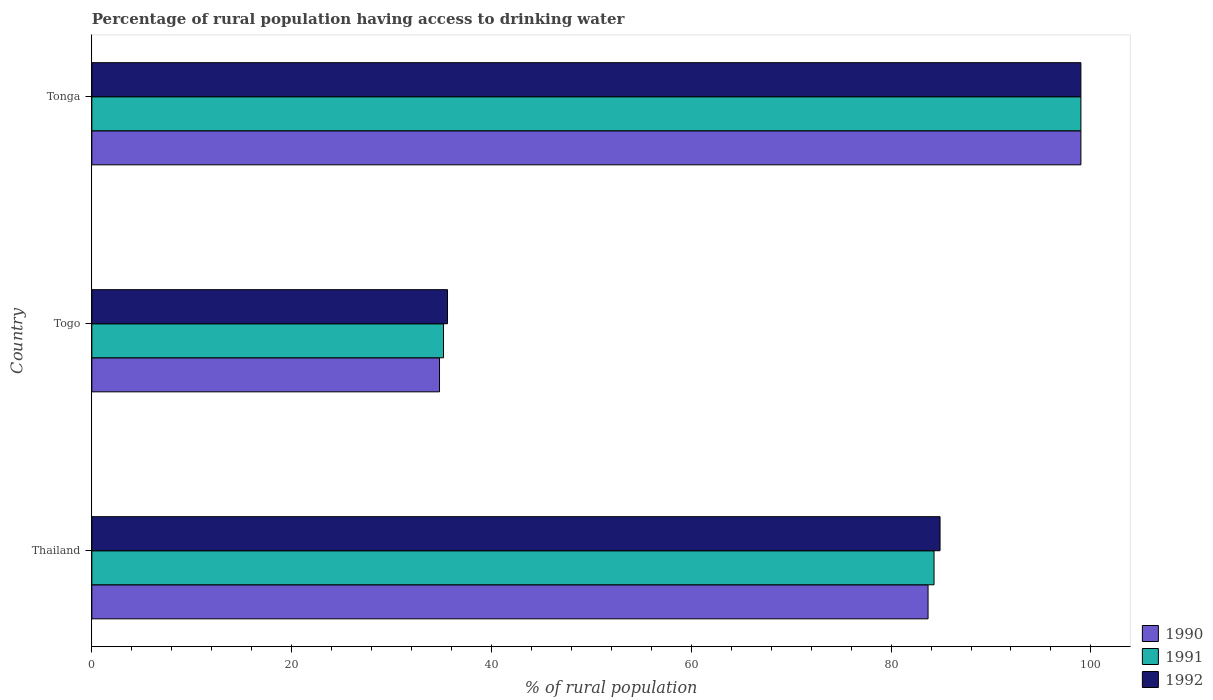How many different coloured bars are there?
Your answer should be compact. 3. How many bars are there on the 1st tick from the bottom?
Your response must be concise. 3. What is the label of the 1st group of bars from the top?
Your answer should be very brief. Tonga. In how many cases, is the number of bars for a given country not equal to the number of legend labels?
Provide a short and direct response. 0. What is the percentage of rural population having access to drinking water in 1990 in Togo?
Ensure brevity in your answer.  34.8. Across all countries, what is the maximum percentage of rural population having access to drinking water in 1991?
Your answer should be compact. 99. Across all countries, what is the minimum percentage of rural population having access to drinking water in 1990?
Keep it short and to the point. 34.8. In which country was the percentage of rural population having access to drinking water in 1992 maximum?
Provide a succinct answer. Tonga. In which country was the percentage of rural population having access to drinking water in 1990 minimum?
Give a very brief answer. Togo. What is the total percentage of rural population having access to drinking water in 1991 in the graph?
Provide a succinct answer. 218.5. What is the difference between the percentage of rural population having access to drinking water in 1990 in Thailand and that in Tonga?
Offer a terse response. -15.3. What is the difference between the percentage of rural population having access to drinking water in 1991 in Tonga and the percentage of rural population having access to drinking water in 1990 in Togo?
Ensure brevity in your answer.  64.2. What is the average percentage of rural population having access to drinking water in 1992 per country?
Provide a succinct answer. 73.17. What is the difference between the percentage of rural population having access to drinking water in 1991 and percentage of rural population having access to drinking water in 1992 in Thailand?
Give a very brief answer. -0.6. In how many countries, is the percentage of rural population having access to drinking water in 1991 greater than 40 %?
Give a very brief answer. 2. What is the ratio of the percentage of rural population having access to drinking water in 1991 in Thailand to that in Tonga?
Ensure brevity in your answer.  0.85. What is the difference between the highest and the second highest percentage of rural population having access to drinking water in 1990?
Provide a succinct answer. 15.3. What is the difference between the highest and the lowest percentage of rural population having access to drinking water in 1990?
Offer a terse response. 64.2. Is the sum of the percentage of rural population having access to drinking water in 1992 in Thailand and Togo greater than the maximum percentage of rural population having access to drinking water in 1990 across all countries?
Keep it short and to the point. Yes. Is it the case that in every country, the sum of the percentage of rural population having access to drinking water in 1992 and percentage of rural population having access to drinking water in 1991 is greater than the percentage of rural population having access to drinking water in 1990?
Provide a short and direct response. Yes. How many bars are there?
Your answer should be very brief. 9. Are all the bars in the graph horizontal?
Offer a very short reply. Yes. How many countries are there in the graph?
Your answer should be very brief. 3. What is the difference between two consecutive major ticks on the X-axis?
Your answer should be compact. 20. Are the values on the major ticks of X-axis written in scientific E-notation?
Your answer should be very brief. No. Does the graph contain any zero values?
Provide a succinct answer. No. How many legend labels are there?
Offer a very short reply. 3. How are the legend labels stacked?
Your answer should be compact. Vertical. What is the title of the graph?
Give a very brief answer. Percentage of rural population having access to drinking water. Does "1975" appear as one of the legend labels in the graph?
Your answer should be very brief. No. What is the label or title of the X-axis?
Your answer should be very brief. % of rural population. What is the % of rural population of 1990 in Thailand?
Offer a very short reply. 83.7. What is the % of rural population in 1991 in Thailand?
Your response must be concise. 84.3. What is the % of rural population in 1992 in Thailand?
Provide a succinct answer. 84.9. What is the % of rural population of 1990 in Togo?
Provide a short and direct response. 34.8. What is the % of rural population in 1991 in Togo?
Offer a terse response. 35.2. What is the % of rural population in 1992 in Togo?
Give a very brief answer. 35.6. What is the % of rural population of 1992 in Tonga?
Your answer should be very brief. 99. Across all countries, what is the minimum % of rural population of 1990?
Provide a short and direct response. 34.8. Across all countries, what is the minimum % of rural population of 1991?
Offer a terse response. 35.2. Across all countries, what is the minimum % of rural population in 1992?
Offer a very short reply. 35.6. What is the total % of rural population of 1990 in the graph?
Your answer should be very brief. 217.5. What is the total % of rural population in 1991 in the graph?
Keep it short and to the point. 218.5. What is the total % of rural population of 1992 in the graph?
Provide a succinct answer. 219.5. What is the difference between the % of rural population of 1990 in Thailand and that in Togo?
Offer a terse response. 48.9. What is the difference between the % of rural population in 1991 in Thailand and that in Togo?
Provide a succinct answer. 49.1. What is the difference between the % of rural population in 1992 in Thailand and that in Togo?
Keep it short and to the point. 49.3. What is the difference between the % of rural population of 1990 in Thailand and that in Tonga?
Offer a very short reply. -15.3. What is the difference between the % of rural population of 1991 in Thailand and that in Tonga?
Your response must be concise. -14.7. What is the difference between the % of rural population of 1992 in Thailand and that in Tonga?
Your answer should be very brief. -14.1. What is the difference between the % of rural population in 1990 in Togo and that in Tonga?
Offer a very short reply. -64.2. What is the difference between the % of rural population of 1991 in Togo and that in Tonga?
Offer a very short reply. -63.8. What is the difference between the % of rural population of 1992 in Togo and that in Tonga?
Your response must be concise. -63.4. What is the difference between the % of rural population of 1990 in Thailand and the % of rural population of 1991 in Togo?
Your answer should be very brief. 48.5. What is the difference between the % of rural population in 1990 in Thailand and the % of rural population in 1992 in Togo?
Your answer should be compact. 48.1. What is the difference between the % of rural population of 1991 in Thailand and the % of rural population of 1992 in Togo?
Your answer should be very brief. 48.7. What is the difference between the % of rural population in 1990 in Thailand and the % of rural population in 1991 in Tonga?
Offer a very short reply. -15.3. What is the difference between the % of rural population in 1990 in Thailand and the % of rural population in 1992 in Tonga?
Provide a short and direct response. -15.3. What is the difference between the % of rural population of 1991 in Thailand and the % of rural population of 1992 in Tonga?
Offer a very short reply. -14.7. What is the difference between the % of rural population in 1990 in Togo and the % of rural population in 1991 in Tonga?
Give a very brief answer. -64.2. What is the difference between the % of rural population of 1990 in Togo and the % of rural population of 1992 in Tonga?
Offer a terse response. -64.2. What is the difference between the % of rural population of 1991 in Togo and the % of rural population of 1992 in Tonga?
Offer a terse response. -63.8. What is the average % of rural population in 1990 per country?
Give a very brief answer. 72.5. What is the average % of rural population in 1991 per country?
Ensure brevity in your answer.  72.83. What is the average % of rural population in 1992 per country?
Make the answer very short. 73.17. What is the difference between the % of rural population in 1990 and % of rural population in 1992 in Thailand?
Your response must be concise. -1.2. What is the difference between the % of rural population in 1991 and % of rural population in 1992 in Thailand?
Your answer should be compact. -0.6. What is the difference between the % of rural population in 1990 and % of rural population in 1991 in Togo?
Your answer should be very brief. -0.4. What is the difference between the % of rural population of 1990 and % of rural population of 1992 in Togo?
Provide a succinct answer. -0.8. What is the difference between the % of rural population in 1991 and % of rural population in 1992 in Togo?
Your response must be concise. -0.4. What is the difference between the % of rural population of 1990 and % of rural population of 1991 in Tonga?
Keep it short and to the point. 0. What is the difference between the % of rural population of 1991 and % of rural population of 1992 in Tonga?
Give a very brief answer. 0. What is the ratio of the % of rural population in 1990 in Thailand to that in Togo?
Offer a very short reply. 2.41. What is the ratio of the % of rural population in 1991 in Thailand to that in Togo?
Provide a short and direct response. 2.39. What is the ratio of the % of rural population in 1992 in Thailand to that in Togo?
Your answer should be compact. 2.38. What is the ratio of the % of rural population in 1990 in Thailand to that in Tonga?
Your answer should be very brief. 0.85. What is the ratio of the % of rural population in 1991 in Thailand to that in Tonga?
Keep it short and to the point. 0.85. What is the ratio of the % of rural population of 1992 in Thailand to that in Tonga?
Your response must be concise. 0.86. What is the ratio of the % of rural population in 1990 in Togo to that in Tonga?
Offer a terse response. 0.35. What is the ratio of the % of rural population in 1991 in Togo to that in Tonga?
Provide a short and direct response. 0.36. What is the ratio of the % of rural population in 1992 in Togo to that in Tonga?
Provide a succinct answer. 0.36. What is the difference between the highest and the second highest % of rural population in 1992?
Provide a succinct answer. 14.1. What is the difference between the highest and the lowest % of rural population in 1990?
Provide a succinct answer. 64.2. What is the difference between the highest and the lowest % of rural population of 1991?
Give a very brief answer. 63.8. What is the difference between the highest and the lowest % of rural population of 1992?
Ensure brevity in your answer.  63.4. 